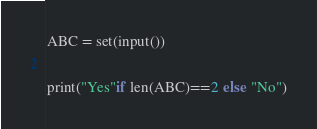Convert code to text. <code><loc_0><loc_0><loc_500><loc_500><_Python_>
ABC = set(input())

print("Yes"if len(ABC)==2 else "No")
</code> 